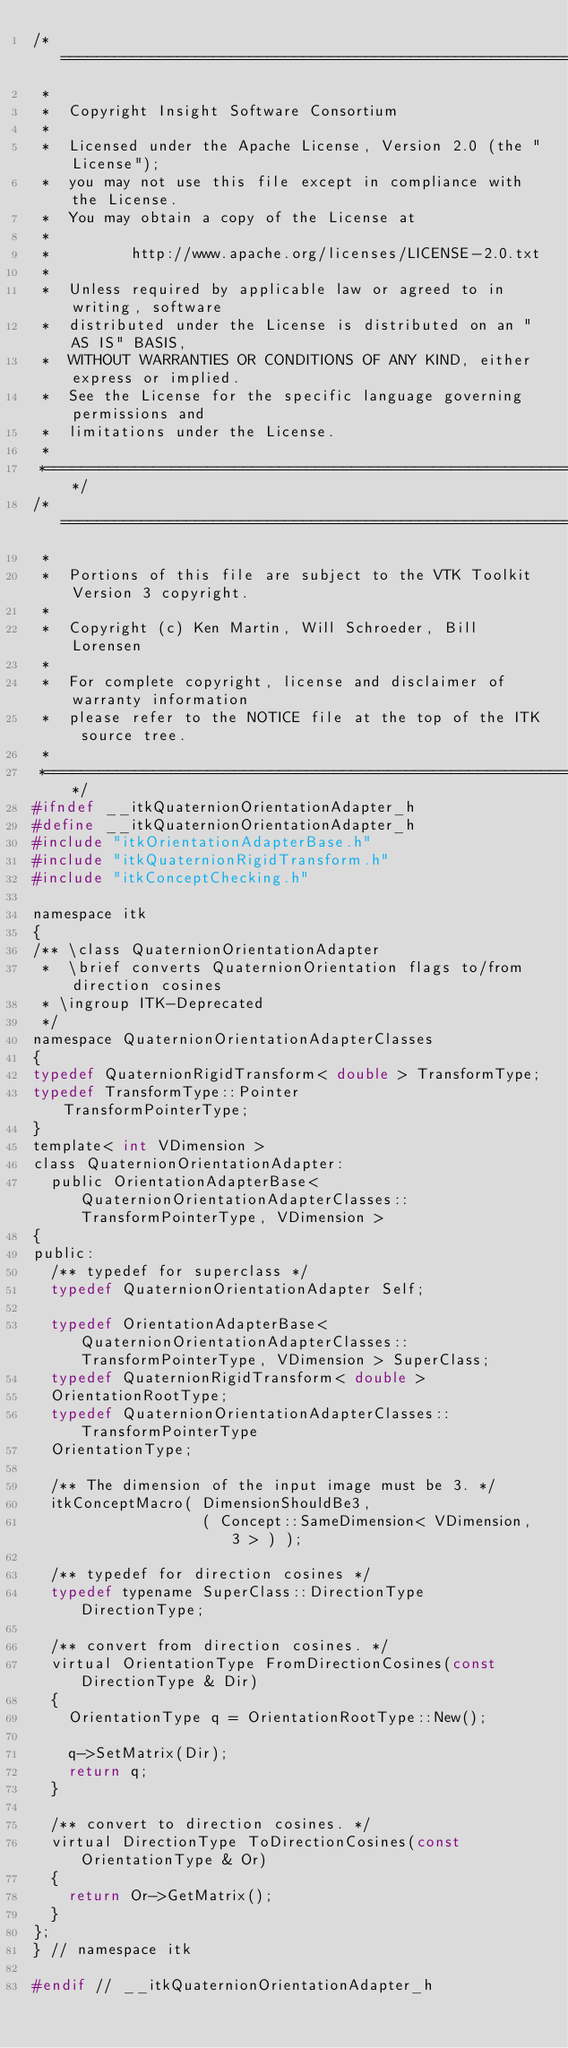<code> <loc_0><loc_0><loc_500><loc_500><_C_>/*=========================================================================
 *
 *  Copyright Insight Software Consortium
 *
 *  Licensed under the Apache License, Version 2.0 (the "License");
 *  you may not use this file except in compliance with the License.
 *  You may obtain a copy of the License at
 *
 *         http://www.apache.org/licenses/LICENSE-2.0.txt
 *
 *  Unless required by applicable law or agreed to in writing, software
 *  distributed under the License is distributed on an "AS IS" BASIS,
 *  WITHOUT WARRANTIES OR CONDITIONS OF ANY KIND, either express or implied.
 *  See the License for the specific language governing permissions and
 *  limitations under the License.
 *
 *=========================================================================*/
/*=========================================================================
 *
 *  Portions of this file are subject to the VTK Toolkit Version 3 copyright.
 *
 *  Copyright (c) Ken Martin, Will Schroeder, Bill Lorensen
 *
 *  For complete copyright, license and disclaimer of warranty information
 *  please refer to the NOTICE file at the top of the ITK source tree.
 *
 *=========================================================================*/
#ifndef __itkQuaternionOrientationAdapter_h
#define __itkQuaternionOrientationAdapter_h
#include "itkOrientationAdapterBase.h"
#include "itkQuaternionRigidTransform.h"
#include "itkConceptChecking.h"

namespace itk
{
/** \class QuaternionOrientationAdapter
 *  \brief converts QuaternionOrientation flags to/from direction cosines
 * \ingroup ITK-Deprecated
 */
namespace QuaternionOrientationAdapterClasses
{
typedef QuaternionRigidTransform< double > TransformType;
typedef TransformType::Pointer             TransformPointerType;
}
template< int VDimension >
class QuaternionOrientationAdapter:
  public OrientationAdapterBase< QuaternionOrientationAdapterClasses::TransformPointerType, VDimension >
{
public:
  /** typedef for superclass */
  typedef QuaternionOrientationAdapter Self;

  typedef OrientationAdapterBase< QuaternionOrientationAdapterClasses::TransformPointerType, VDimension > SuperClass;
  typedef QuaternionRigidTransform< double >
  OrientationRootType;
  typedef QuaternionOrientationAdapterClasses::TransformPointerType
  OrientationType;

  /** The dimension of the input image must be 3. */
  itkConceptMacro( DimensionShouldBe3,
                   ( Concept::SameDimension< VDimension, 3 > ) );

  /** typedef for direction cosines */
  typedef typename SuperClass::DirectionType DirectionType;

  /** convert from direction cosines. */
  virtual OrientationType FromDirectionCosines(const DirectionType & Dir)
  {
    OrientationType q = OrientationRootType::New();

    q->SetMatrix(Dir);
    return q;
  }

  /** convert to direction cosines. */
  virtual DirectionType ToDirectionCosines(const OrientationType & Or)
  {
    return Or->GetMatrix();
  }
};
} // namespace itk

#endif // __itkQuaternionOrientationAdapter_h
</code> 